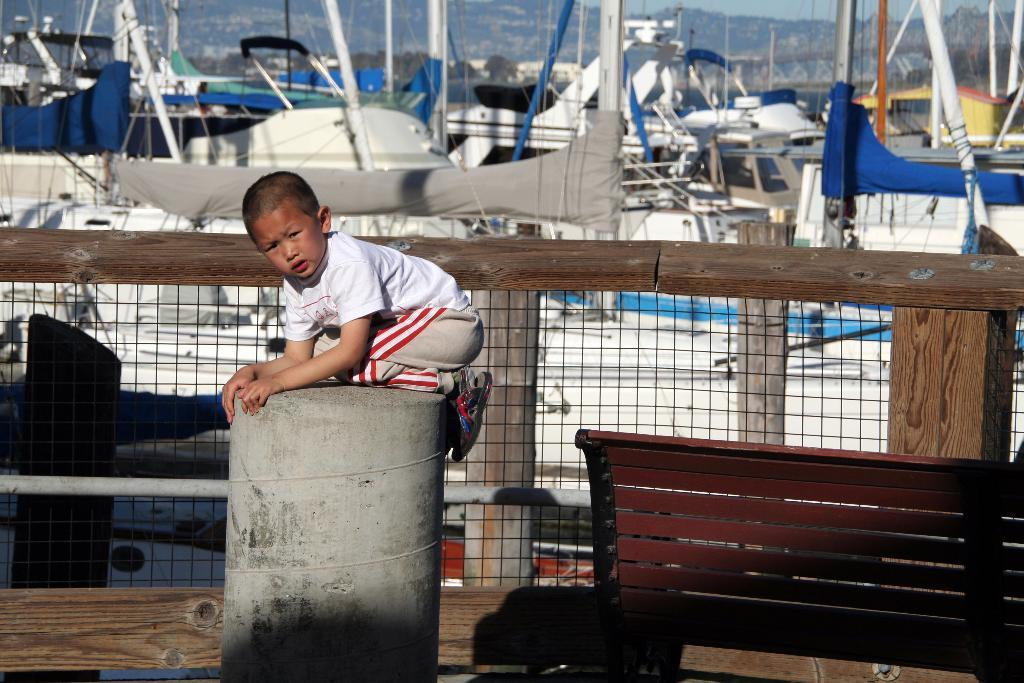Who is the main subject in the image? There is a boy in the image. What is the boy wearing? The boy is wearing a white shirt. What object can be seen on the right side of the image? There is a bench on the right side of the image. What can be seen in the distance in the image? Boats are visible in the background of the image. What type of tomatoes can be seen growing on the bench in the image? There are no tomatoes visible in the image, and the bench is not associated with any plants or gardening. 